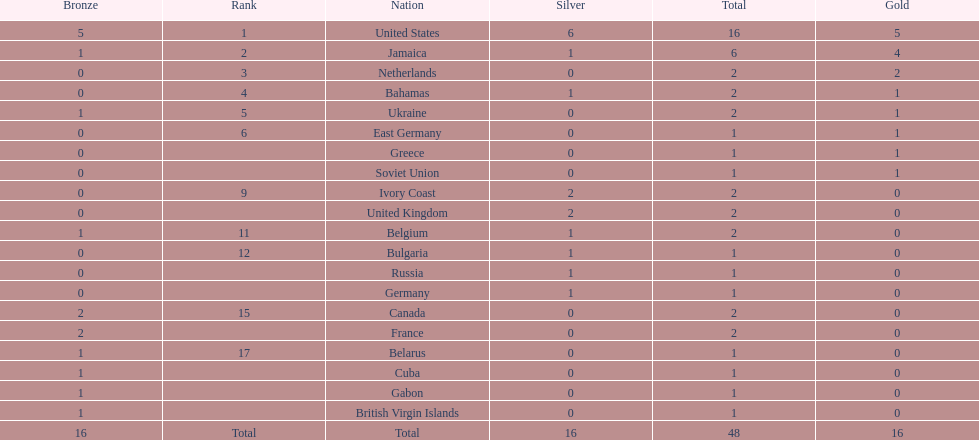How many countries have managed to secure at least two gold medals? 3. 